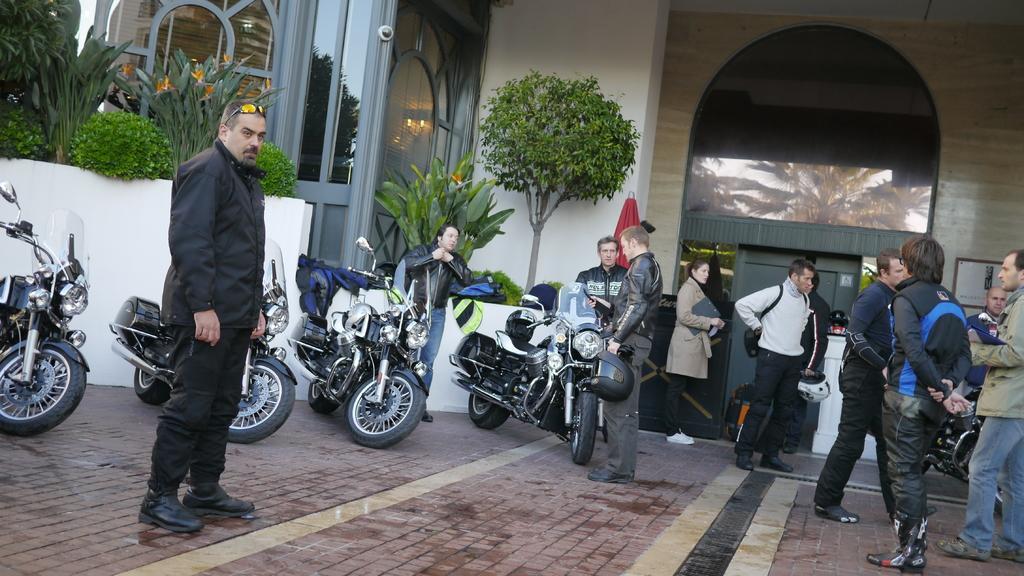How would you summarize this image in a sentence or two? In the image there is a pavement and on that there are bikes and people, behind the people there are plants, doors and walls. 